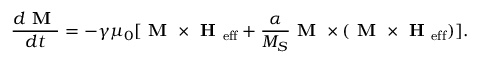<formula> <loc_0><loc_0><loc_500><loc_500>\frac { d M } { d t } = - \gamma \mu _ { 0 } [ M \times H _ { e f f } + \frac { \alpha } { M _ { S } } M \times ( M \times H _ { e f f } ) ] .</formula> 